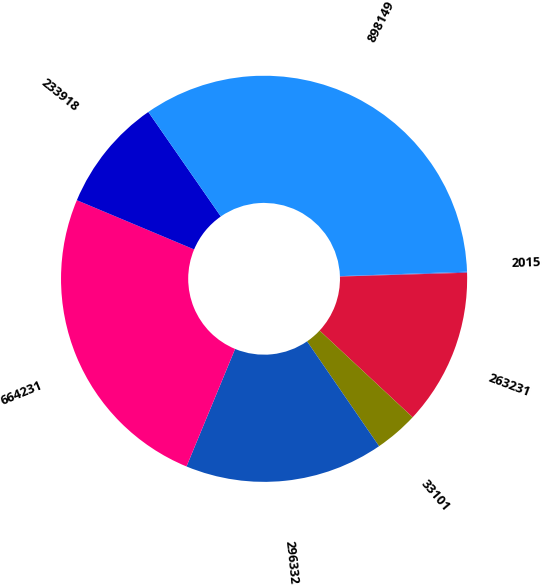<chart> <loc_0><loc_0><loc_500><loc_500><pie_chart><fcel>2015<fcel>263231<fcel>33101<fcel>296332<fcel>664231<fcel>233918<fcel>898149<nl><fcel>0.08%<fcel>12.42%<fcel>3.48%<fcel>15.82%<fcel>25.09%<fcel>9.02%<fcel>34.1%<nl></chart> 